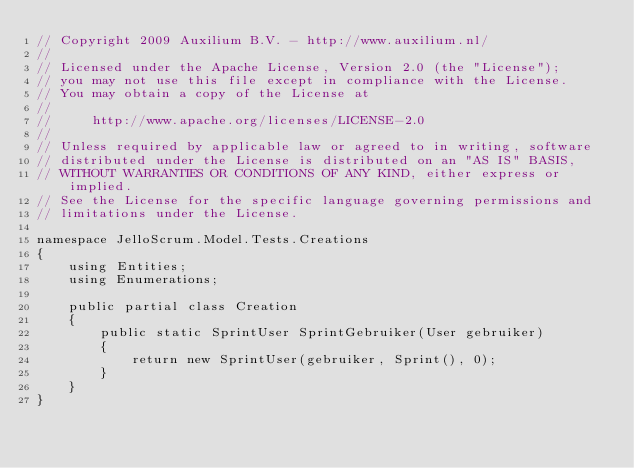<code> <loc_0><loc_0><loc_500><loc_500><_C#_>// Copyright 2009 Auxilium B.V. - http://www.auxilium.nl/
// 
// Licensed under the Apache License, Version 2.0 (the "License");
// you may not use this file except in compliance with the License.
// You may obtain a copy of the License at
// 
//     http://www.apache.org/licenses/LICENSE-2.0
// 
// Unless required by applicable law or agreed to in writing, software
// distributed under the License is distributed on an "AS IS" BASIS,
// WITHOUT WARRANTIES OR CONDITIONS OF ANY KIND, either express or implied.
// See the License for the specific language governing permissions and
// limitations under the License.

namespace JelloScrum.Model.Tests.Creations
{
    using Entities;
    using Enumerations;

    public partial class Creation
    {
        public static SprintUser SprintGebruiker(User gebruiker)
        {
            return new SprintUser(gebruiker, Sprint(), 0);
        }
    }
}</code> 